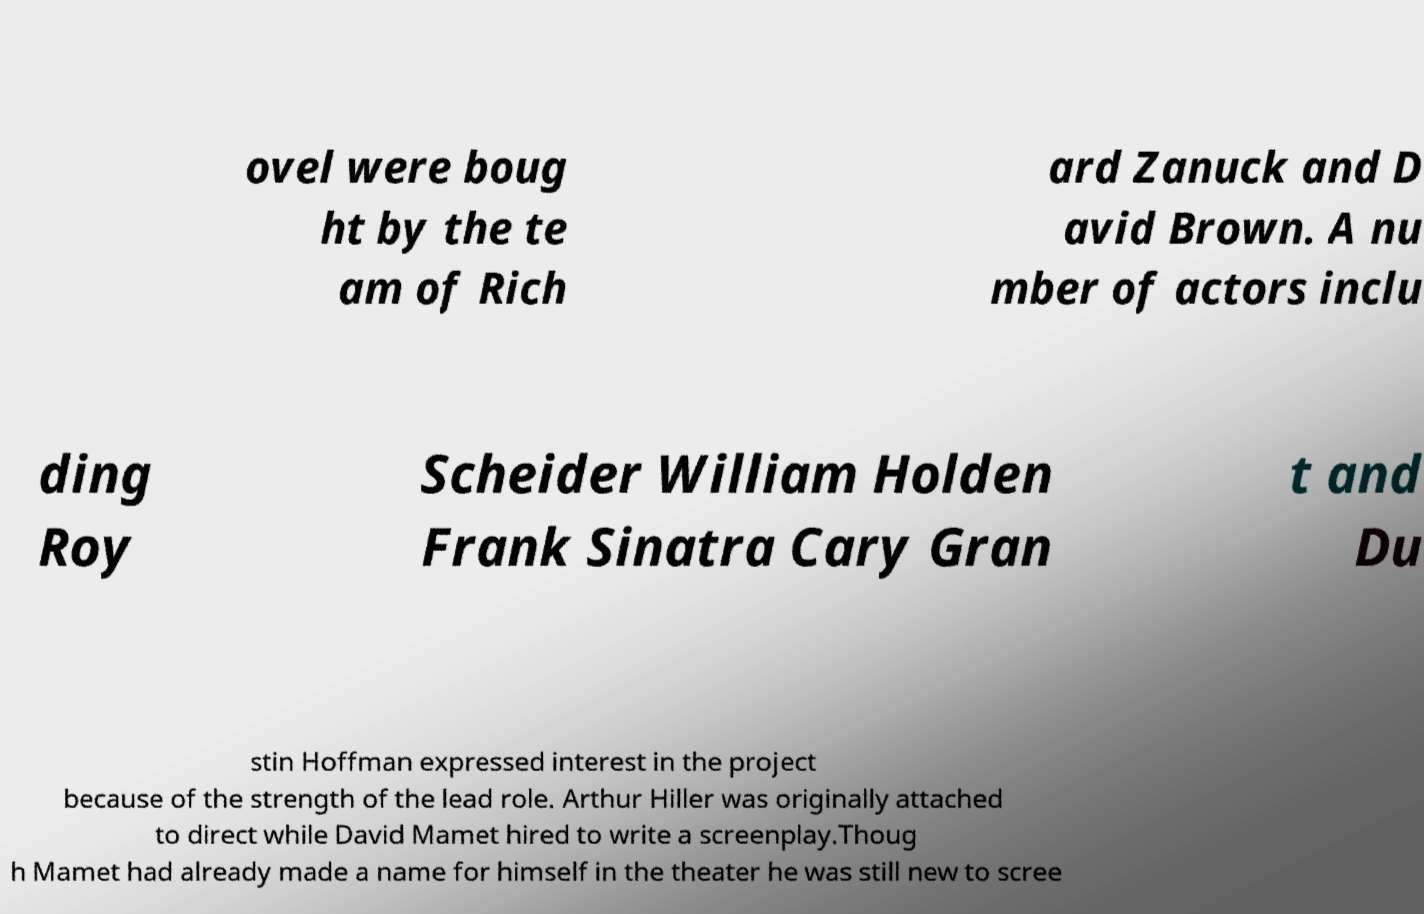Can you read and provide the text displayed in the image?This photo seems to have some interesting text. Can you extract and type it out for me? ovel were boug ht by the te am of Rich ard Zanuck and D avid Brown. A nu mber of actors inclu ding Roy Scheider William Holden Frank Sinatra Cary Gran t and Du stin Hoffman expressed interest in the project because of the strength of the lead role. Arthur Hiller was originally attached to direct while David Mamet hired to write a screenplay.Thoug h Mamet had already made a name for himself in the theater he was still new to scree 